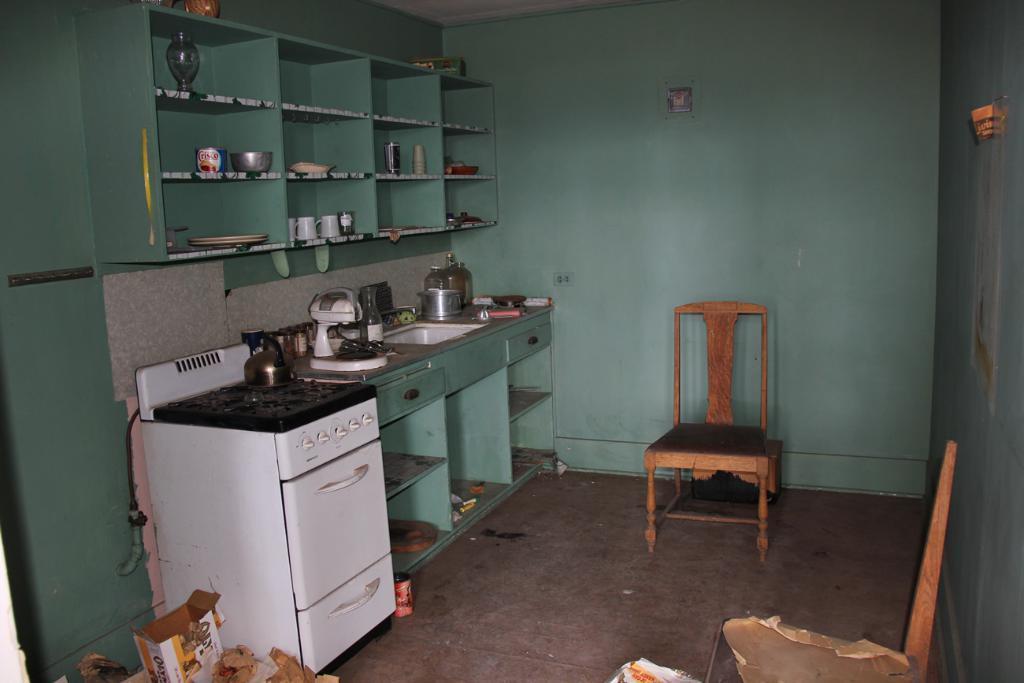How would you summarize this image in a sentence or two? In this picture I can see a kettle on the stove, there is a dishwasher, there is a cake mixer, wash basin and some other objects on the cabinet, there are plates, glasses and some other items in and on the shelves, there is a chair, cardboard box and some other objects. 